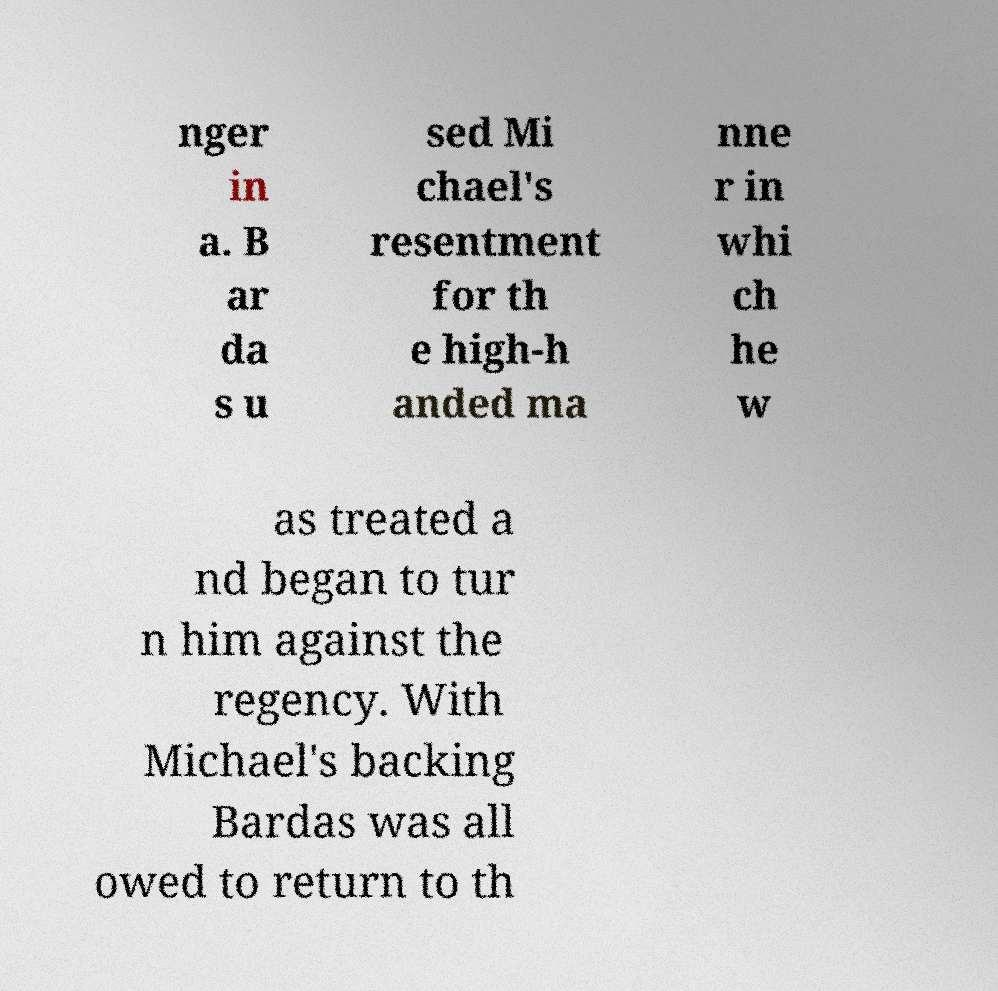Please identify and transcribe the text found in this image. nger in a. B ar da s u sed Mi chael's resentment for th e high-h anded ma nne r in whi ch he w as treated a nd began to tur n him against the regency. With Michael's backing Bardas was all owed to return to th 